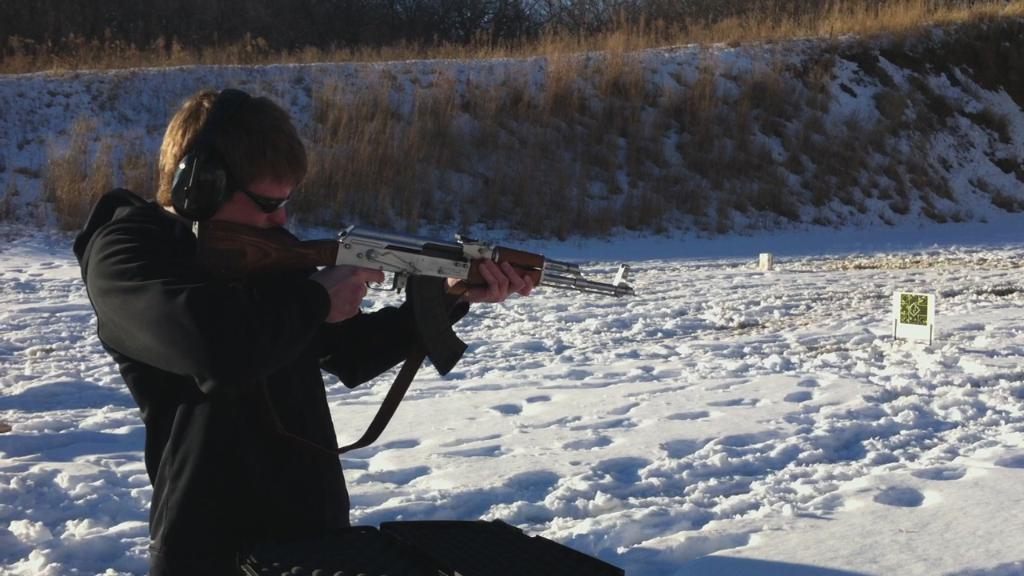Describe this image in one or two sentences. In this image we can see a man is wearing black color dress and holding gun, the surface of the land is covered with snow. Background of the image trees and grass is present. 